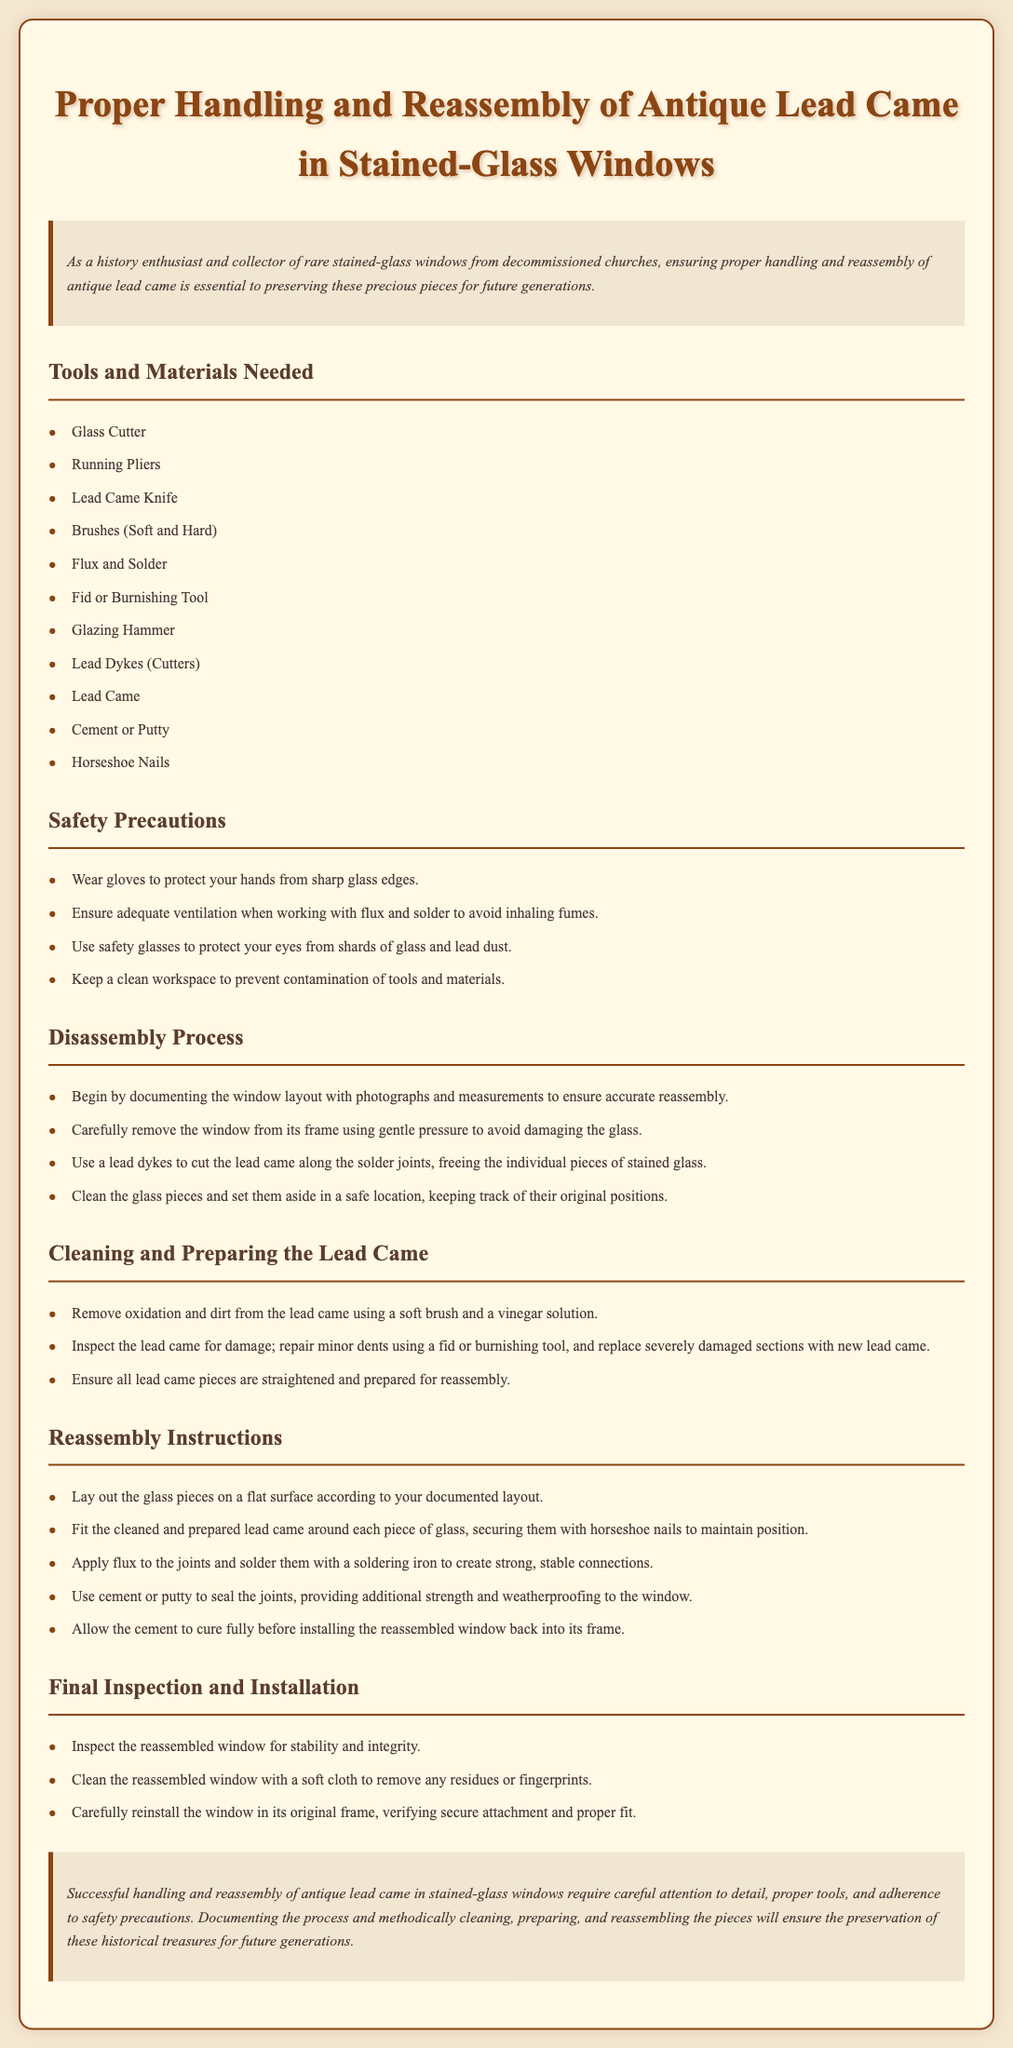what is the title of the document? The title of the document, as indicated in the header, describes the main focus of the content.
Answer: Proper Handling and Reassembly of Antique Lead Came in Stained-Glass Windows how many tools and materials are listed? The document provides a numbered list of tools and materials needed for the process, which can be counted.
Answer: 11 what is the main safety precaution about working with flux and solder? This safety precaution highlights the importance of working conditions to avoid health risks.
Answer: Ensure adequate ventilation what should you do before removing the window from its frame? This step is crucial to ensure a smooth disassembly process and to safeguard the structure of the window.
Answer: Document the window layout which tool is recommended for removing oxidation from lead came? This specifies the type of tool suggested for cleaning purposes within the document.
Answer: Soft brush how are the glass pieces positioned during reassembly? This indicates the importance of organization in the process for effective reassembly.
Answer: According to your documented layout what should be used to seal the joints after soldering? This part of the document emphasizes the final step in ensuring the structural integrity of the window.
Answer: Cement or putty what is suggested for the final clean-up of the reassembled window? This instruction ensures that the surface of the window is free from any work residues.
Answer: Soft cloth what must be checked before reinstalling the window? This ensures that the integrity and safety of the construction meet necessary requirements before installation.
Answer: Stability and integrity 